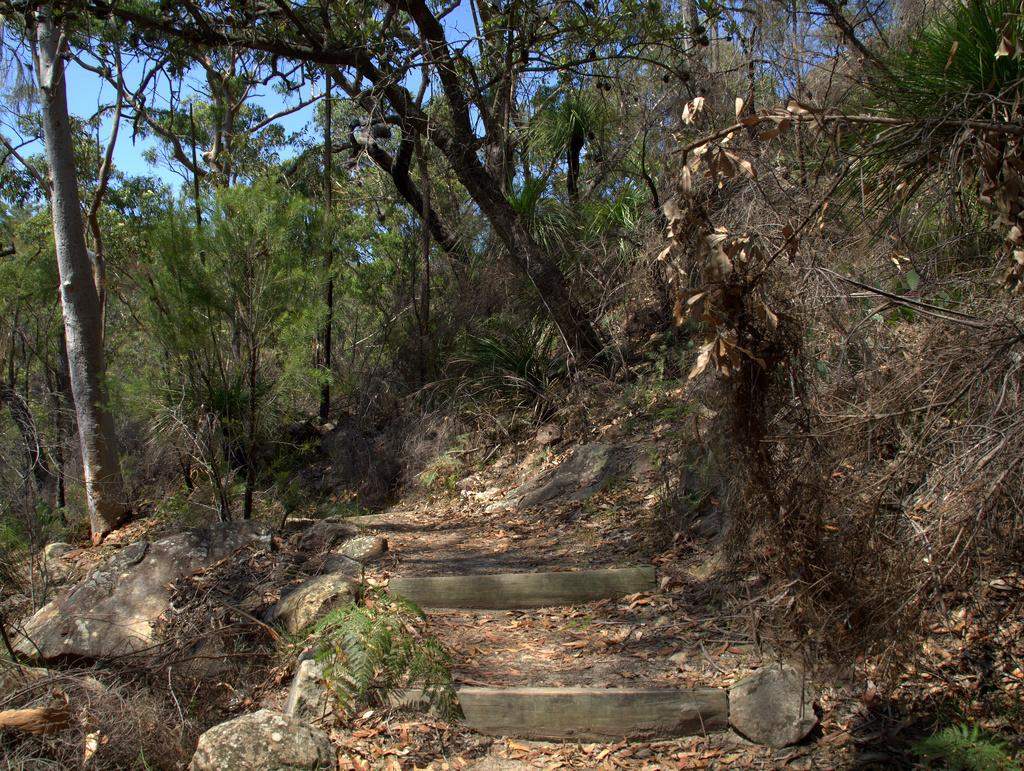What type of cases are visible in the image? There are star cases in the image. What natural elements can be seen in the image? There are rocks and trees in the image. Where are the kittens playing with the meat in the image? There are no kittens or meat present in the image. What type of pen is used to draw the trees in the image? The image does not depict a drawing or any pen used to create it. 